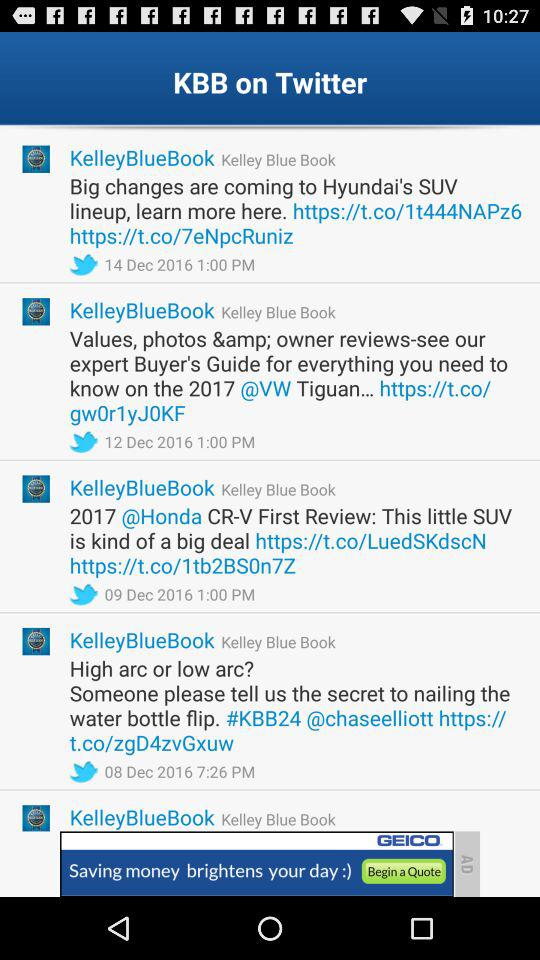What is the full form of KBB? The full form of KBB is "Kelley Blue Book". 